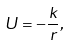<formula> <loc_0><loc_0><loc_500><loc_500>U = - \frac { k } { r } ,</formula> 